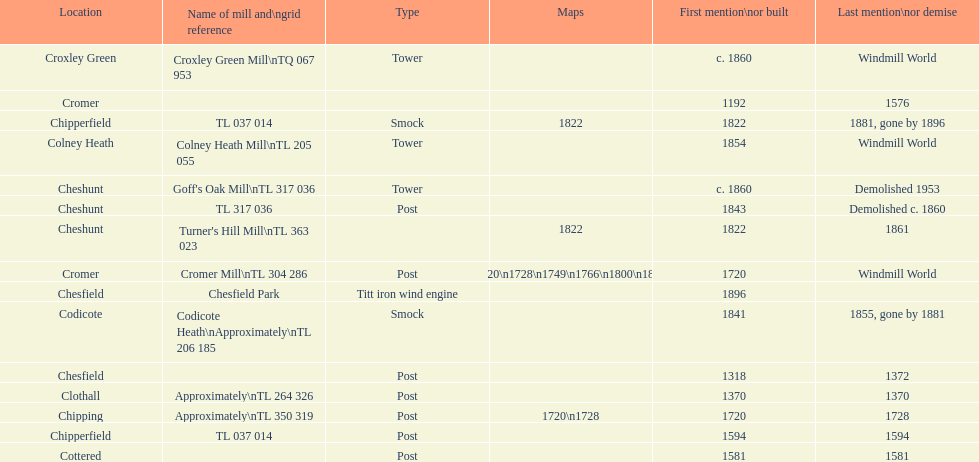Did cromer, chipperfield or cheshunt have the most windmills? Cheshunt. 